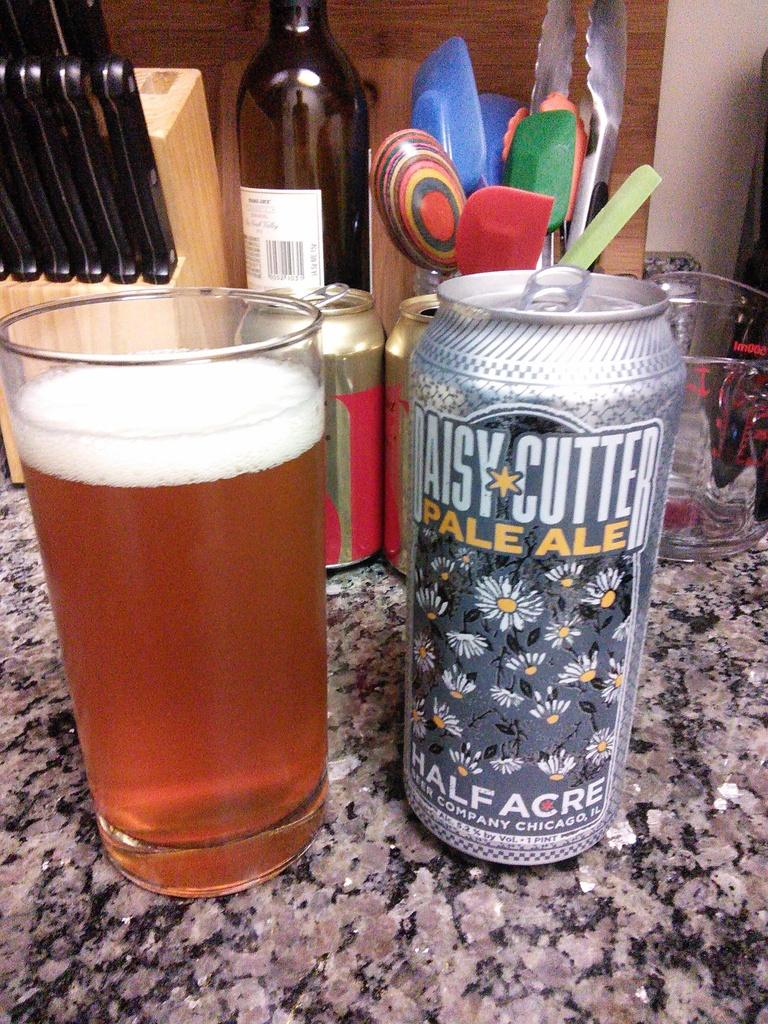What type of containers are visible in the image? There are beverage cans in the image. What else can be seen in the image besides the cans? There are glasses, kitchen tools, a bottle, and some unspecified objects in the image. What can be inferred about the location of the image? The image is likely taken in a room. What type of heart is visible in the image? There is no heart present in the image. How much salt is visible in the image? There is no salt present in the image. 